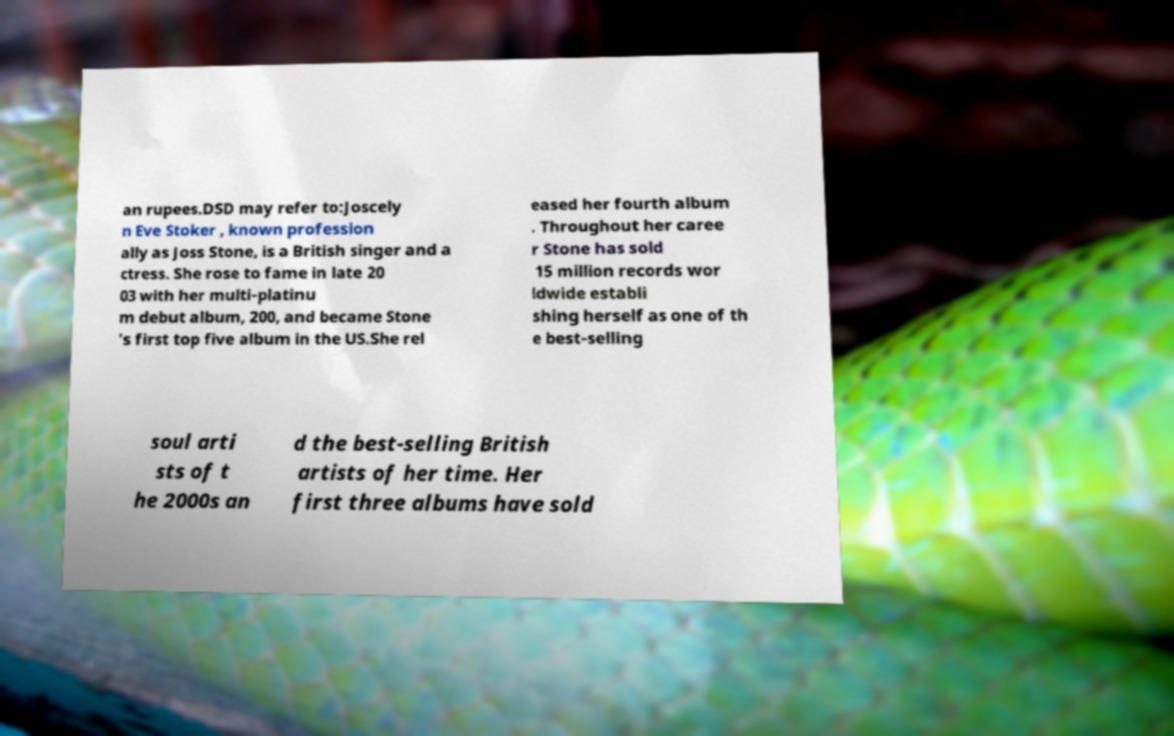I need the written content from this picture converted into text. Can you do that? an rupees.DSD may refer to:Joscely n Eve Stoker , known profession ally as Joss Stone, is a British singer and a ctress. She rose to fame in late 20 03 with her multi-platinu m debut album, 200, and became Stone 's first top five album in the US.She rel eased her fourth album . Throughout her caree r Stone has sold 15 million records wor ldwide establi shing herself as one of th e best-selling soul arti sts of t he 2000s an d the best-selling British artists of her time. Her first three albums have sold 